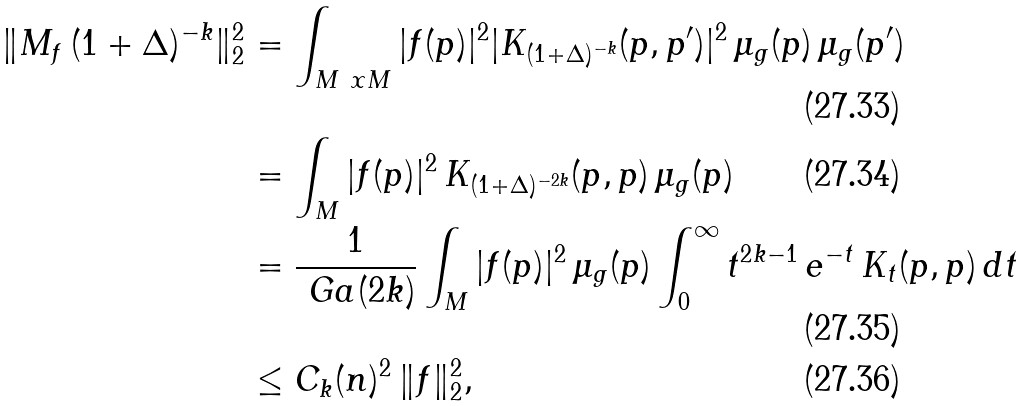Convert formula to latex. <formula><loc_0><loc_0><loc_500><loc_500>\| M _ { f } \, ( 1 + \Delta ) ^ { - k } \| _ { 2 } ^ { 2 } & = \int _ { M \ x M } | f ( p ) | ^ { 2 } | K _ { ( 1 + \Delta ) ^ { - k } } ( p , p ^ { \prime } ) | ^ { 2 } \, \mu _ { g } ( p ) \, \mu _ { g } ( p ^ { \prime } ) \\ & = \int _ { M } | f ( p ) | ^ { 2 } \, K _ { ( 1 + \Delta ) ^ { - 2 k } } ( p , p ) \, \mu _ { g } ( p ) \\ & = \frac { 1 } { \ G a ( 2 k ) } \int _ { M } | f ( p ) | ^ { 2 } \, \mu _ { g } ( p ) \int _ { 0 } ^ { \infty } t ^ { 2 k - 1 } \, e ^ { - t } \, K _ { t } ( p , p ) \, d t \\ & \leq C _ { k } ( n ) ^ { 2 } \, \| f \| _ { 2 } ^ { 2 } ,</formula> 